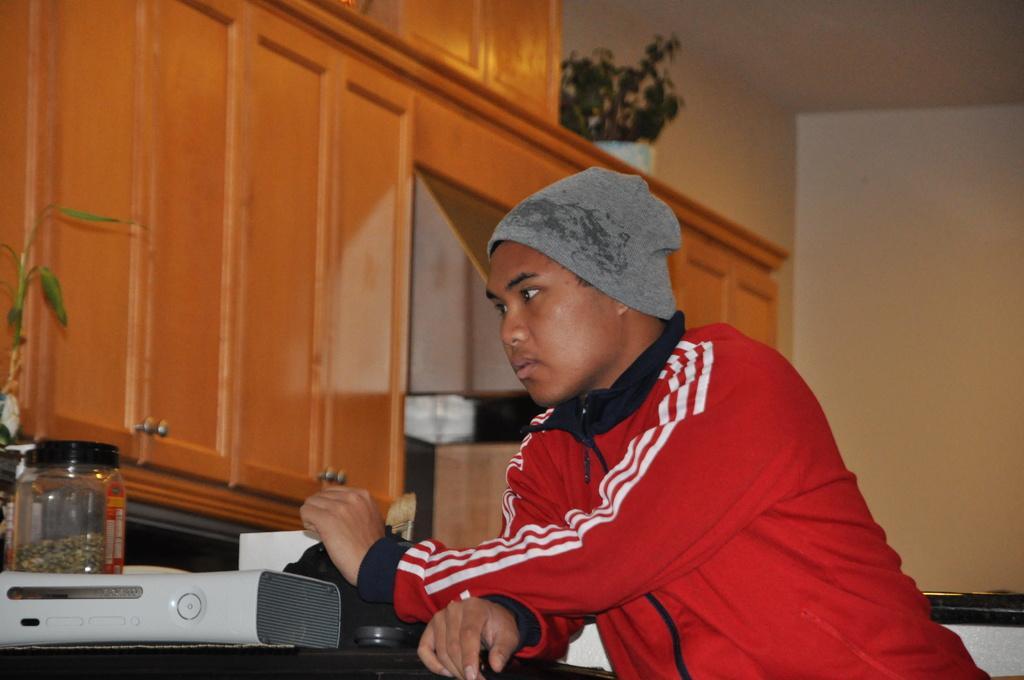How would you summarize this image in a sentence or two? In this image we can see a person wearing a red color jacket, in front of him we can see a table, on the table there is a jar and some other objects, there is a potted plant on the cupboards and in the background we can see the wall. 